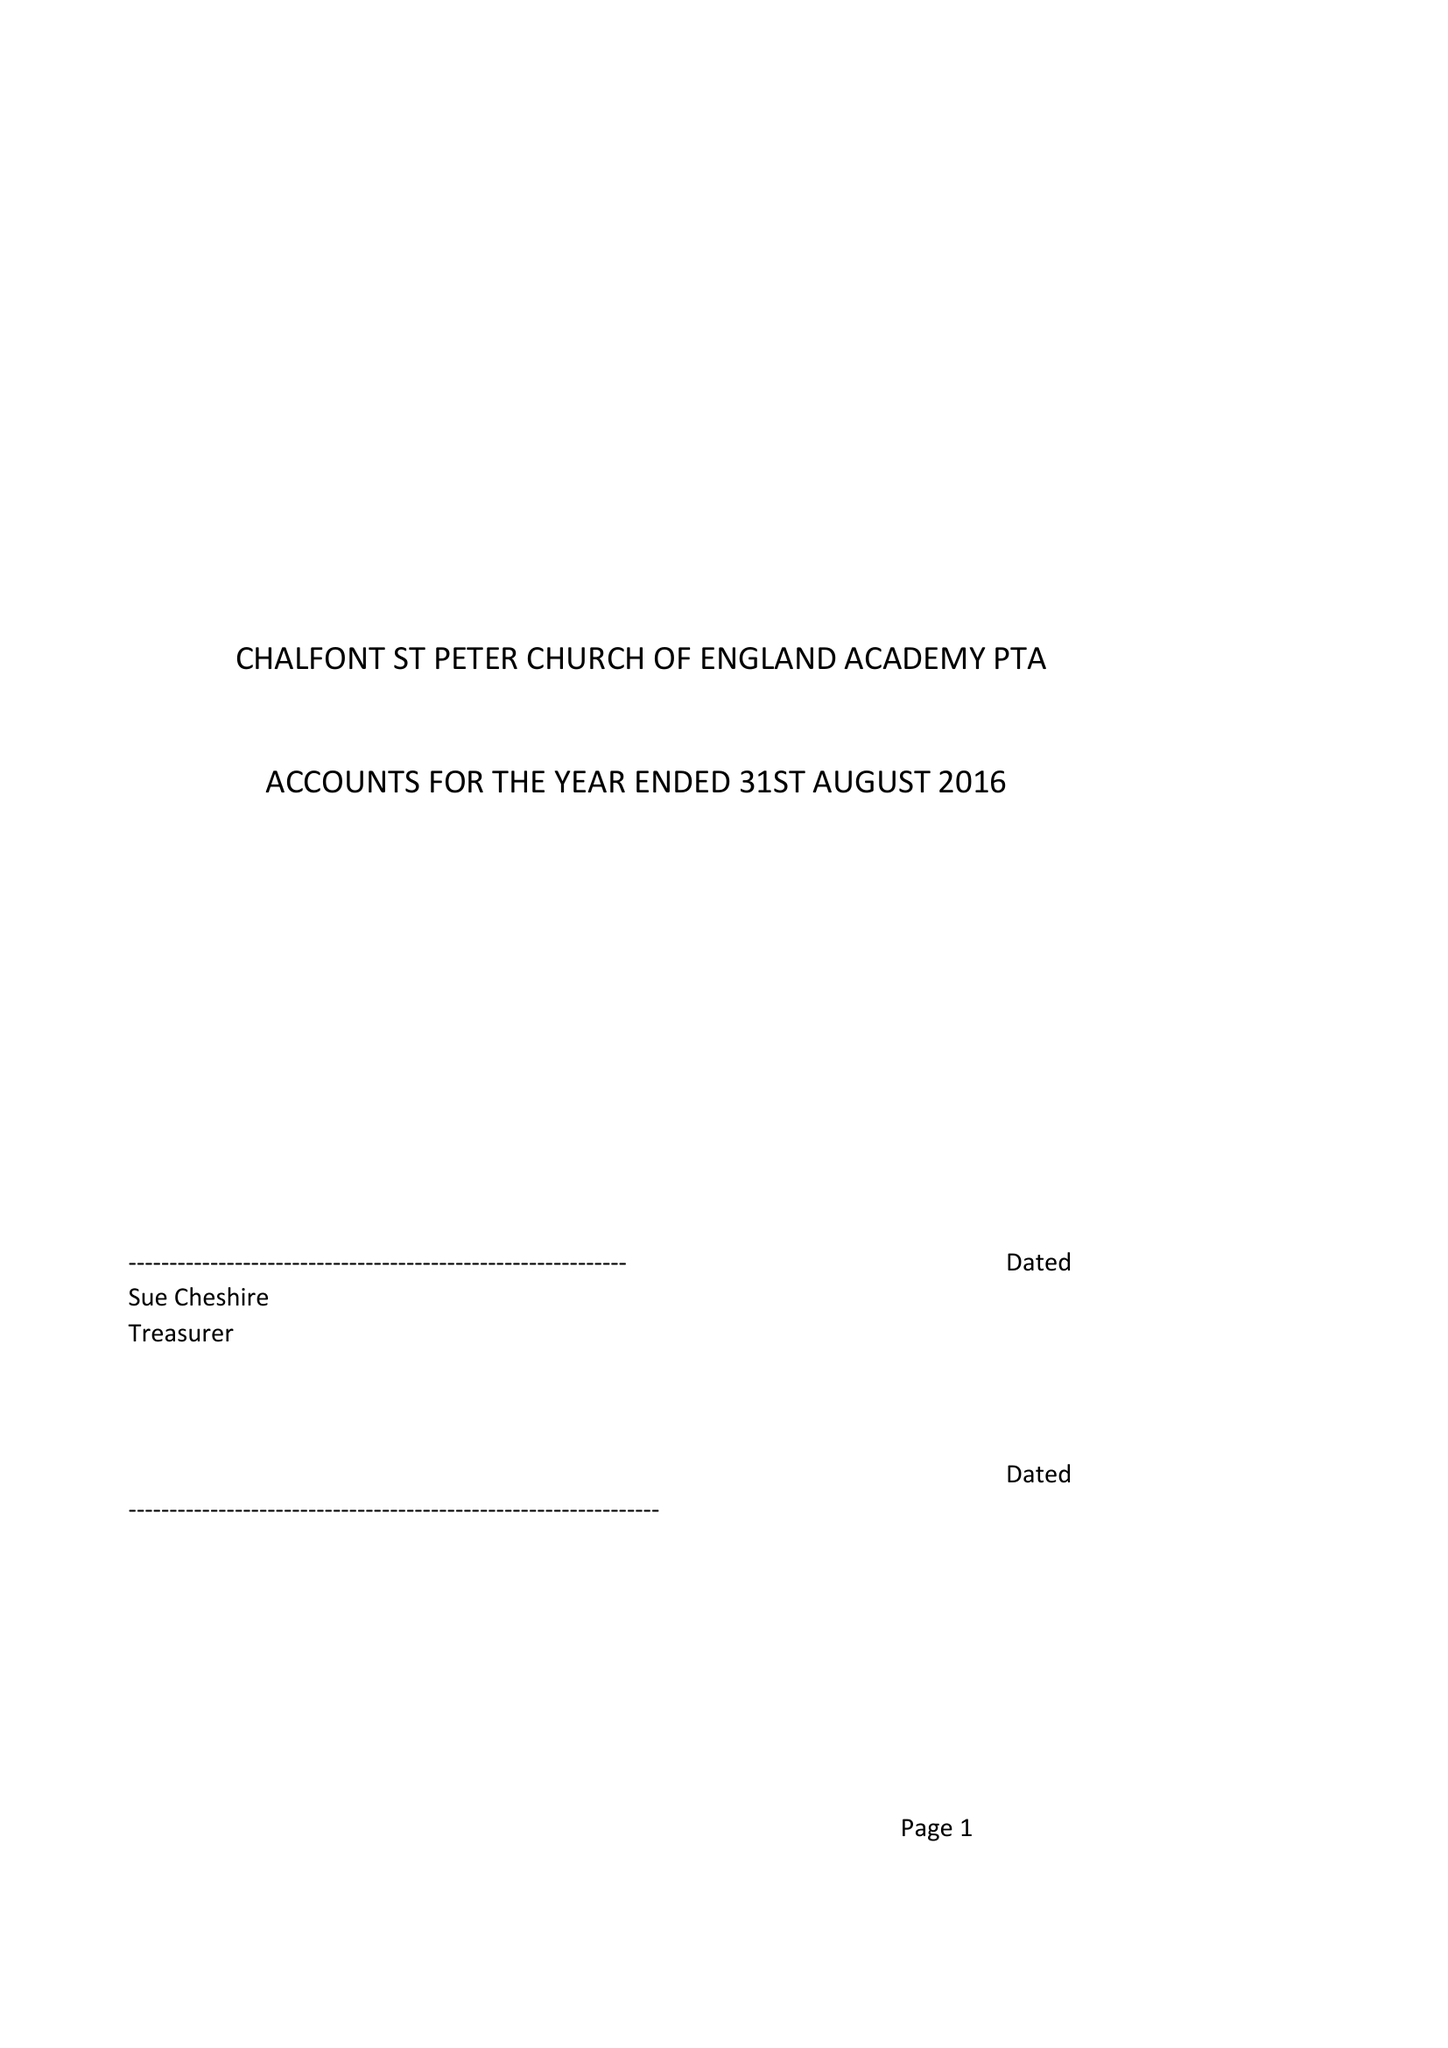What is the value for the address__post_town?
Answer the question using a single word or phrase. GERRARDS CROSS 